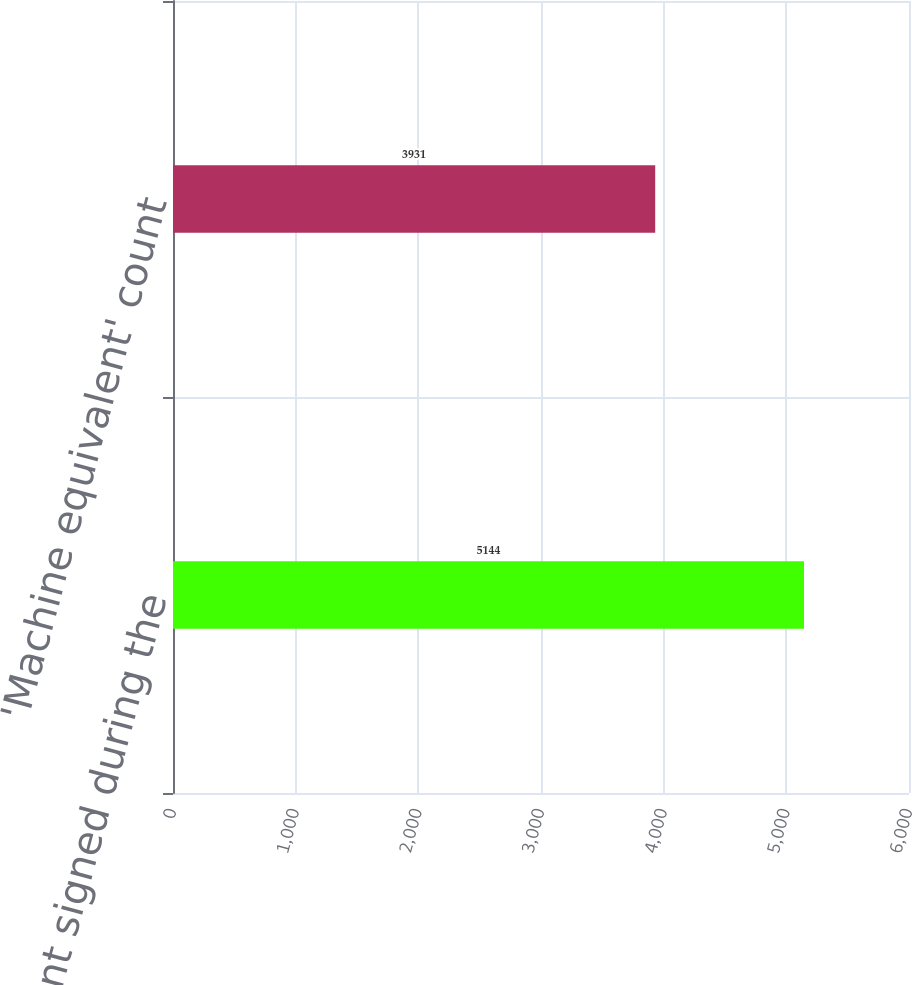<chart> <loc_0><loc_0><loc_500><loc_500><bar_chart><fcel>Device count signed during the<fcel>'Machine equivalent' count<nl><fcel>5144<fcel>3931<nl></chart> 